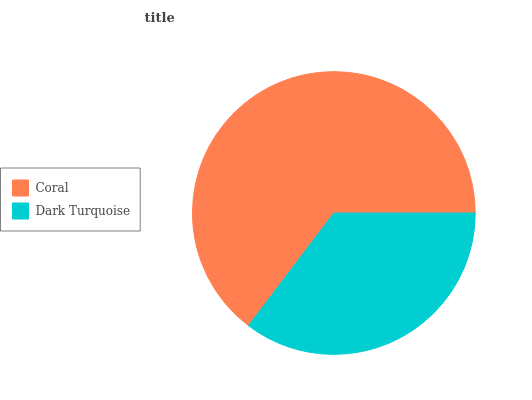Is Dark Turquoise the minimum?
Answer yes or no. Yes. Is Coral the maximum?
Answer yes or no. Yes. Is Dark Turquoise the maximum?
Answer yes or no. No. Is Coral greater than Dark Turquoise?
Answer yes or no. Yes. Is Dark Turquoise less than Coral?
Answer yes or no. Yes. Is Dark Turquoise greater than Coral?
Answer yes or no. No. Is Coral less than Dark Turquoise?
Answer yes or no. No. Is Coral the high median?
Answer yes or no. Yes. Is Dark Turquoise the low median?
Answer yes or no. Yes. Is Dark Turquoise the high median?
Answer yes or no. No. Is Coral the low median?
Answer yes or no. No. 